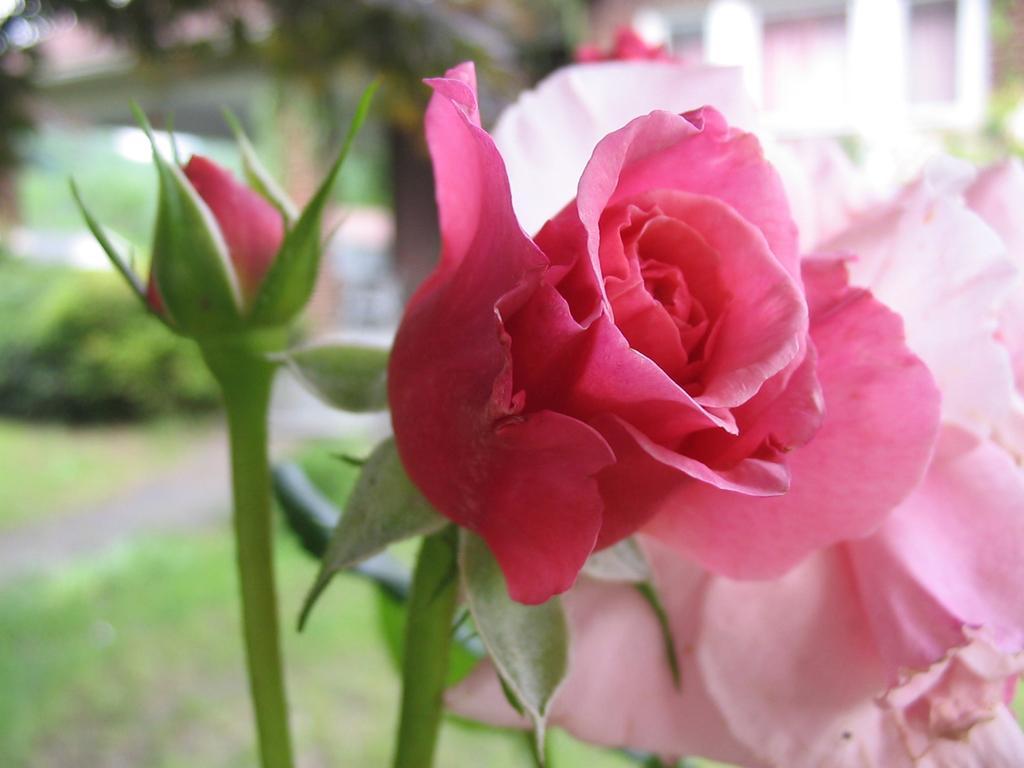Can you describe this image briefly? In this picture we can see rose flowers, bud and in the background we can see trees, building, grass and it is blurry. 